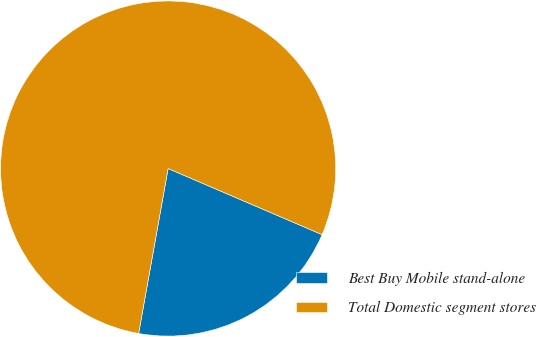Convert chart. <chart><loc_0><loc_0><loc_500><loc_500><pie_chart><fcel>Best Buy Mobile stand-alone<fcel>Total Domestic segment stores<nl><fcel>21.36%<fcel>78.64%<nl></chart> 